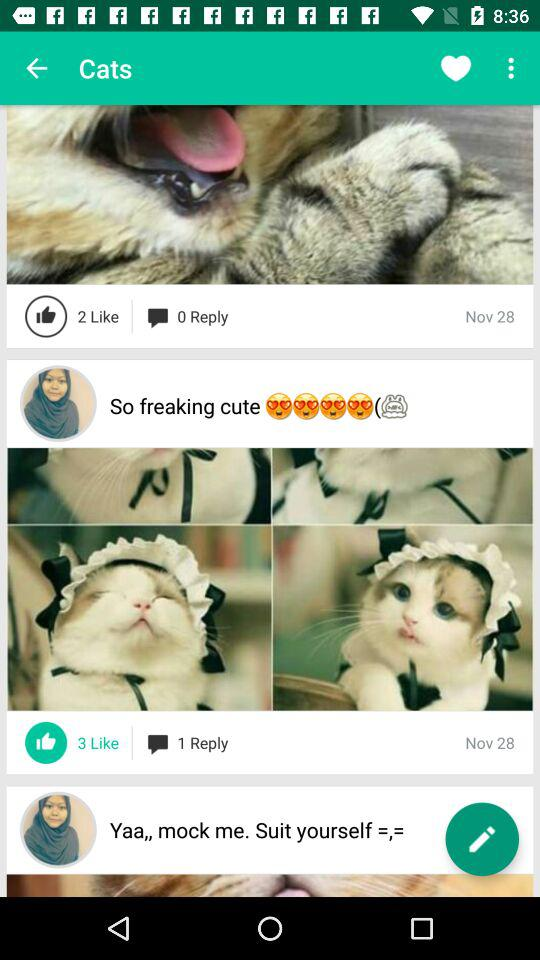How many likes are there of the "So freaking cute" post? There are 3 likes of the "So freaking cute" post. 